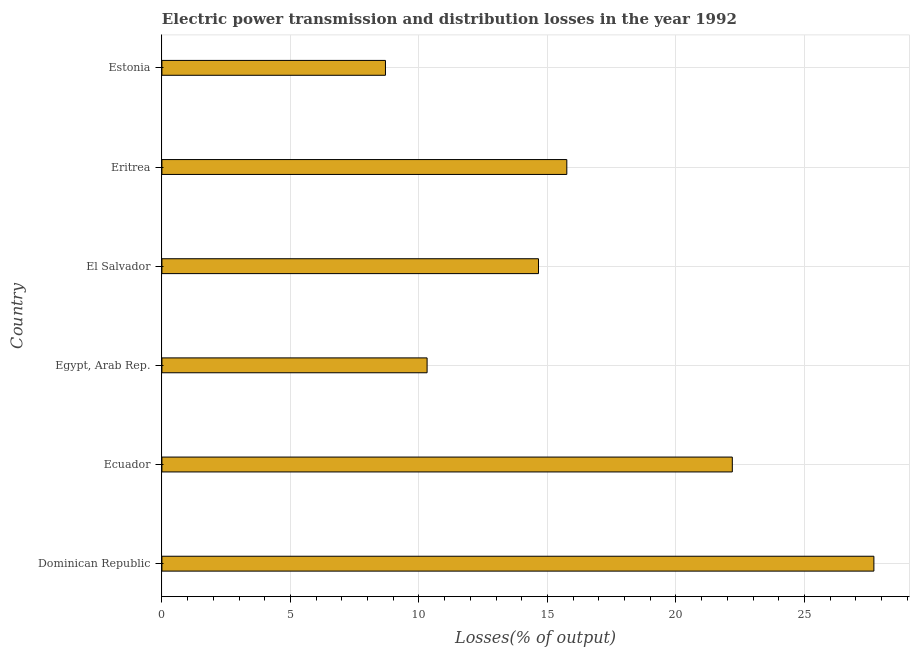Does the graph contain any zero values?
Offer a very short reply. No. Does the graph contain grids?
Provide a short and direct response. Yes. What is the title of the graph?
Offer a very short reply. Electric power transmission and distribution losses in the year 1992. What is the label or title of the X-axis?
Offer a terse response. Losses(% of output). What is the electric power transmission and distribution losses in El Salvador?
Your response must be concise. 14.65. Across all countries, what is the maximum electric power transmission and distribution losses?
Offer a very short reply. 27.7. Across all countries, what is the minimum electric power transmission and distribution losses?
Your answer should be very brief. 8.7. In which country was the electric power transmission and distribution losses maximum?
Your response must be concise. Dominican Republic. In which country was the electric power transmission and distribution losses minimum?
Your answer should be compact. Estonia. What is the sum of the electric power transmission and distribution losses?
Offer a very short reply. 99.31. What is the difference between the electric power transmission and distribution losses in Dominican Republic and Eritrea?
Make the answer very short. 11.95. What is the average electric power transmission and distribution losses per country?
Keep it short and to the point. 16.55. What is the median electric power transmission and distribution losses?
Make the answer very short. 15.2. In how many countries, is the electric power transmission and distribution losses greater than 6 %?
Your answer should be compact. 6. What is the ratio of the electric power transmission and distribution losses in Egypt, Arab Rep. to that in Eritrea?
Give a very brief answer. 0.66. What is the difference between the highest and the second highest electric power transmission and distribution losses?
Make the answer very short. 5.51. What is the difference between the highest and the lowest electric power transmission and distribution losses?
Ensure brevity in your answer.  19. How many bars are there?
Offer a terse response. 6. How many countries are there in the graph?
Ensure brevity in your answer.  6. What is the Losses(% of output) in Dominican Republic?
Offer a terse response. 27.7. What is the Losses(% of output) of Ecuador?
Provide a succinct answer. 22.19. What is the Losses(% of output) in Egypt, Arab Rep.?
Make the answer very short. 10.32. What is the Losses(% of output) in El Salvador?
Your answer should be compact. 14.65. What is the Losses(% of output) of Eritrea?
Offer a terse response. 15.75. What is the Losses(% of output) in Estonia?
Offer a very short reply. 8.7. What is the difference between the Losses(% of output) in Dominican Republic and Ecuador?
Provide a succinct answer. 5.51. What is the difference between the Losses(% of output) in Dominican Republic and Egypt, Arab Rep.?
Offer a terse response. 17.38. What is the difference between the Losses(% of output) in Dominican Republic and El Salvador?
Keep it short and to the point. 13.05. What is the difference between the Losses(% of output) in Dominican Republic and Eritrea?
Offer a very short reply. 11.95. What is the difference between the Losses(% of output) in Dominican Republic and Estonia?
Your answer should be very brief. 19. What is the difference between the Losses(% of output) in Ecuador and Egypt, Arab Rep.?
Offer a terse response. 11.88. What is the difference between the Losses(% of output) in Ecuador and El Salvador?
Ensure brevity in your answer.  7.54. What is the difference between the Losses(% of output) in Ecuador and Eritrea?
Your answer should be very brief. 6.44. What is the difference between the Losses(% of output) in Ecuador and Estonia?
Provide a short and direct response. 13.5. What is the difference between the Losses(% of output) in Egypt, Arab Rep. and El Salvador?
Give a very brief answer. -4.33. What is the difference between the Losses(% of output) in Egypt, Arab Rep. and Eritrea?
Your answer should be compact. -5.44. What is the difference between the Losses(% of output) in Egypt, Arab Rep. and Estonia?
Provide a succinct answer. 1.62. What is the difference between the Losses(% of output) in El Salvador and Eritrea?
Your response must be concise. -1.1. What is the difference between the Losses(% of output) in El Salvador and Estonia?
Make the answer very short. 5.95. What is the difference between the Losses(% of output) in Eritrea and Estonia?
Your response must be concise. 7.06. What is the ratio of the Losses(% of output) in Dominican Republic to that in Ecuador?
Your answer should be compact. 1.25. What is the ratio of the Losses(% of output) in Dominican Republic to that in Egypt, Arab Rep.?
Offer a terse response. 2.69. What is the ratio of the Losses(% of output) in Dominican Republic to that in El Salvador?
Provide a short and direct response. 1.89. What is the ratio of the Losses(% of output) in Dominican Republic to that in Eritrea?
Your answer should be compact. 1.76. What is the ratio of the Losses(% of output) in Dominican Republic to that in Estonia?
Your response must be concise. 3.19. What is the ratio of the Losses(% of output) in Ecuador to that in Egypt, Arab Rep.?
Provide a succinct answer. 2.15. What is the ratio of the Losses(% of output) in Ecuador to that in El Salvador?
Give a very brief answer. 1.51. What is the ratio of the Losses(% of output) in Ecuador to that in Eritrea?
Make the answer very short. 1.41. What is the ratio of the Losses(% of output) in Ecuador to that in Estonia?
Give a very brief answer. 2.55. What is the ratio of the Losses(% of output) in Egypt, Arab Rep. to that in El Salvador?
Offer a very short reply. 0.7. What is the ratio of the Losses(% of output) in Egypt, Arab Rep. to that in Eritrea?
Offer a terse response. 0.66. What is the ratio of the Losses(% of output) in Egypt, Arab Rep. to that in Estonia?
Offer a terse response. 1.19. What is the ratio of the Losses(% of output) in El Salvador to that in Eritrea?
Your response must be concise. 0.93. What is the ratio of the Losses(% of output) in El Salvador to that in Estonia?
Provide a succinct answer. 1.69. What is the ratio of the Losses(% of output) in Eritrea to that in Estonia?
Ensure brevity in your answer.  1.81. 